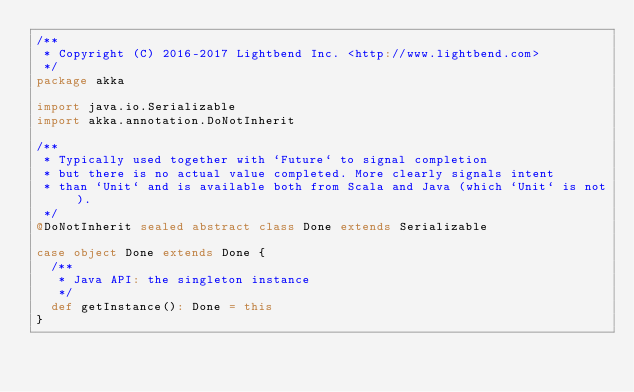<code> <loc_0><loc_0><loc_500><loc_500><_Scala_>/**
 * Copyright (C) 2016-2017 Lightbend Inc. <http://www.lightbend.com>
 */
package akka

import java.io.Serializable
import akka.annotation.DoNotInherit

/**
 * Typically used together with `Future` to signal completion
 * but there is no actual value completed. More clearly signals intent
 * than `Unit` and is available both from Scala and Java (which `Unit` is not).
 */
@DoNotInherit sealed abstract class Done extends Serializable

case object Done extends Done {
  /**
   * Java API: the singleton instance
   */
  def getInstance(): Done = this
}
</code> 